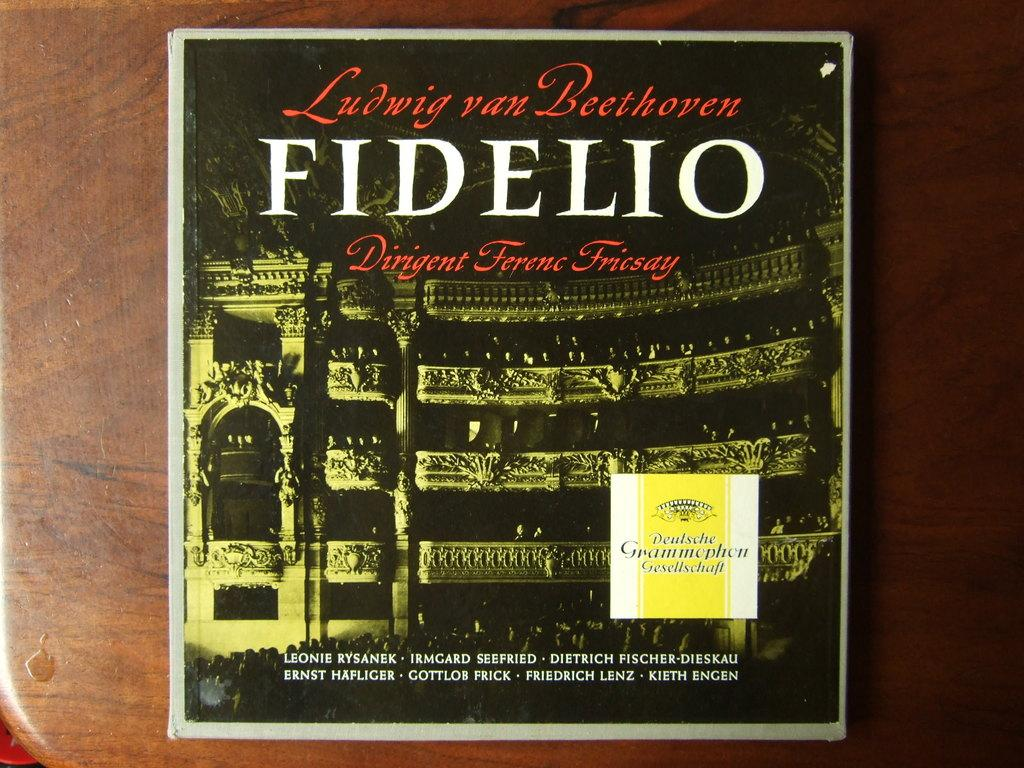Provide a one-sentence caption for the provided image. An album on a table shows Beethoven's name in front of a building. 